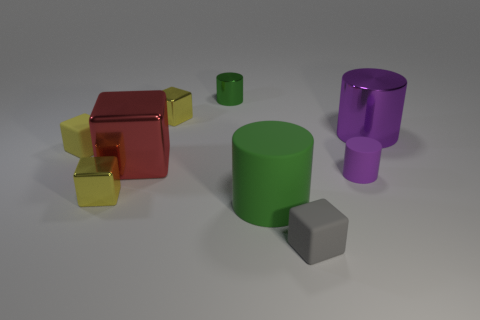What is the material of the other cylinder that is the same color as the large rubber cylinder? The other cylinder sharing the same vivid green color as the large rubber cylinder appears to be made of a glossy, reflective material, which is indicative of metals or polished plastics in a rendered image such as this. 